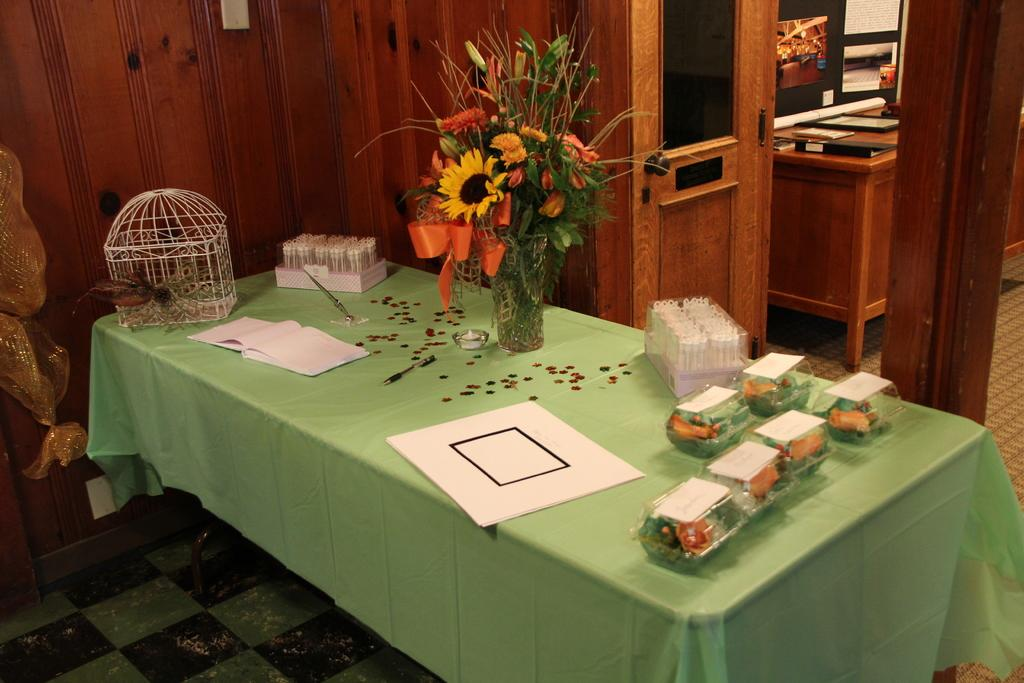What is on the floor in the image? There is a table on the floor in the image. What is on the table? There is a flower vase, papers, and other objects on the table. Can you describe the flower vase? The flower vase is on the table. What else can be seen in the image? There is a door in the image. What type of wine is being served in the image? There is no wine present in the image. What is being smashed on the table in the image? There is no smashing or destruction happening in the image. 